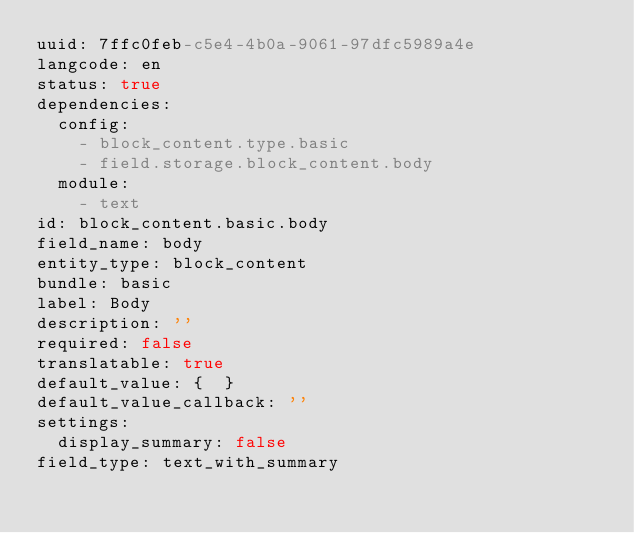Convert code to text. <code><loc_0><loc_0><loc_500><loc_500><_YAML_>uuid: 7ffc0feb-c5e4-4b0a-9061-97dfc5989a4e
langcode: en
status: true
dependencies:
  config:
    - block_content.type.basic
    - field.storage.block_content.body
  module:
    - text
id: block_content.basic.body
field_name: body
entity_type: block_content
bundle: basic
label: Body
description: ''
required: false
translatable: true
default_value: {  }
default_value_callback: ''
settings:
  display_summary: false
field_type: text_with_summary
</code> 